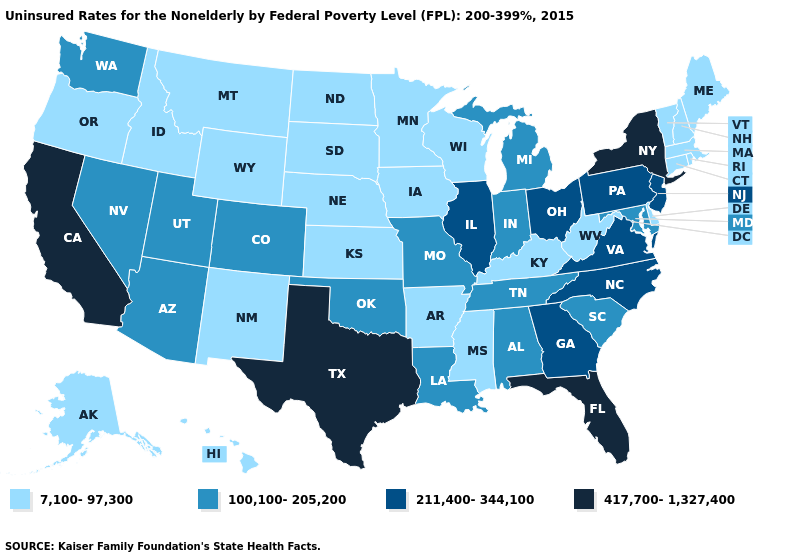Does Wisconsin have the lowest value in the USA?
Quick response, please. Yes. Among the states that border Colorado , which have the lowest value?
Keep it brief. Kansas, Nebraska, New Mexico, Wyoming. Does the first symbol in the legend represent the smallest category?
Write a very short answer. Yes. What is the highest value in the MidWest ?
Be succinct. 211,400-344,100. Name the states that have a value in the range 211,400-344,100?
Concise answer only. Georgia, Illinois, New Jersey, North Carolina, Ohio, Pennsylvania, Virginia. Name the states that have a value in the range 417,700-1,327,400?
Concise answer only. California, Florida, New York, Texas. Name the states that have a value in the range 417,700-1,327,400?
Keep it brief. California, Florida, New York, Texas. Among the states that border Colorado , which have the lowest value?
Concise answer only. Kansas, Nebraska, New Mexico, Wyoming. Name the states that have a value in the range 417,700-1,327,400?
Answer briefly. California, Florida, New York, Texas. Does Georgia have the lowest value in the USA?
Give a very brief answer. No. What is the value of Illinois?
Short answer required. 211,400-344,100. Does the first symbol in the legend represent the smallest category?
Answer briefly. Yes. What is the lowest value in the Northeast?
Quick response, please. 7,100-97,300. What is the value of Tennessee?
Keep it brief. 100,100-205,200. Does Indiana have the lowest value in the MidWest?
Write a very short answer. No. 